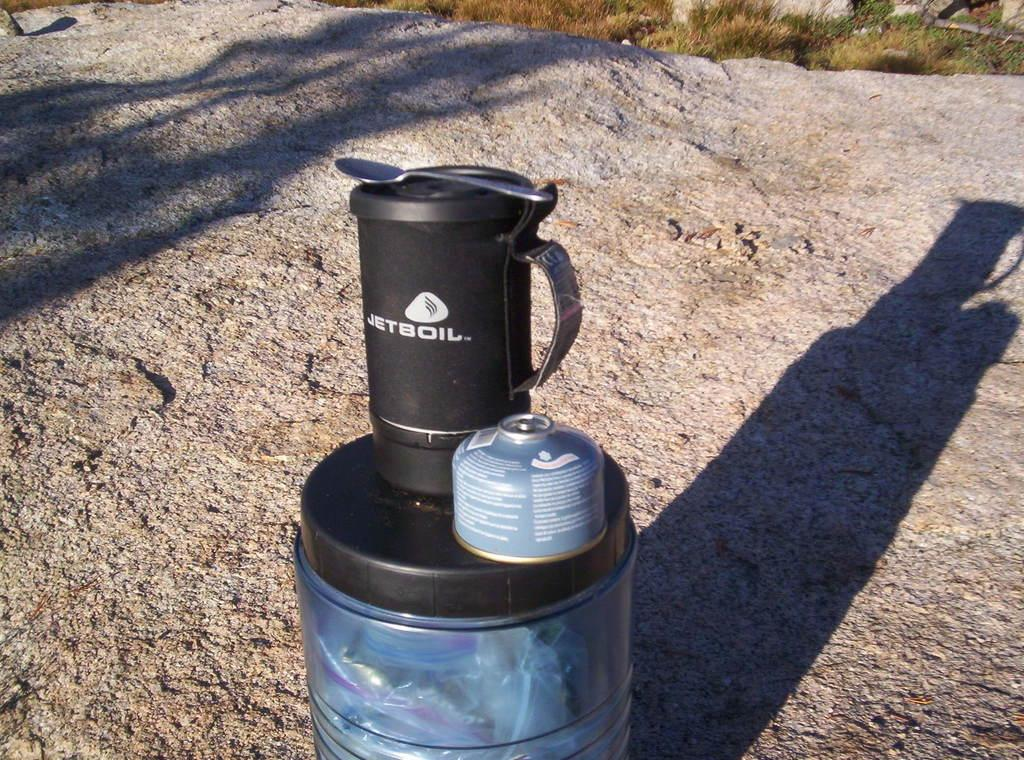<image>
Offer a succinct explanation of the picture presented. A container with JETBOIL sits atop another container 